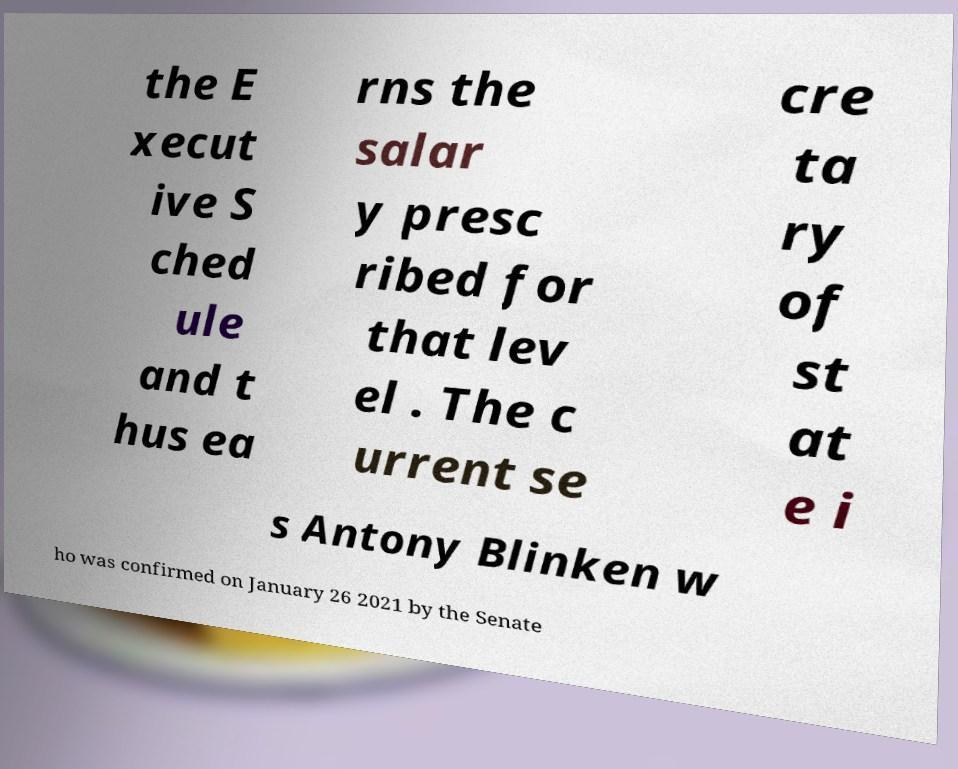I need the written content from this picture converted into text. Can you do that? the E xecut ive S ched ule and t hus ea rns the salar y presc ribed for that lev el . The c urrent se cre ta ry of st at e i s Antony Blinken w ho was confirmed on January 26 2021 by the Senate 